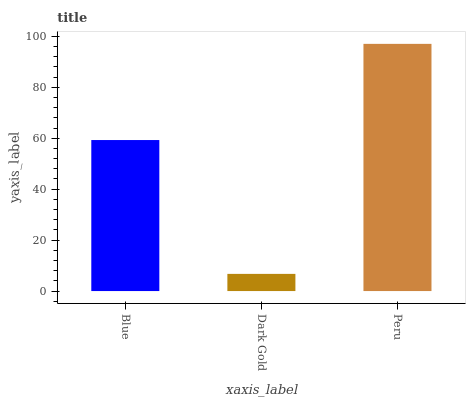Is Peru the minimum?
Answer yes or no. No. Is Dark Gold the maximum?
Answer yes or no. No. Is Peru greater than Dark Gold?
Answer yes or no. Yes. Is Dark Gold less than Peru?
Answer yes or no. Yes. Is Dark Gold greater than Peru?
Answer yes or no. No. Is Peru less than Dark Gold?
Answer yes or no. No. Is Blue the high median?
Answer yes or no. Yes. Is Blue the low median?
Answer yes or no. Yes. Is Dark Gold the high median?
Answer yes or no. No. Is Peru the low median?
Answer yes or no. No. 